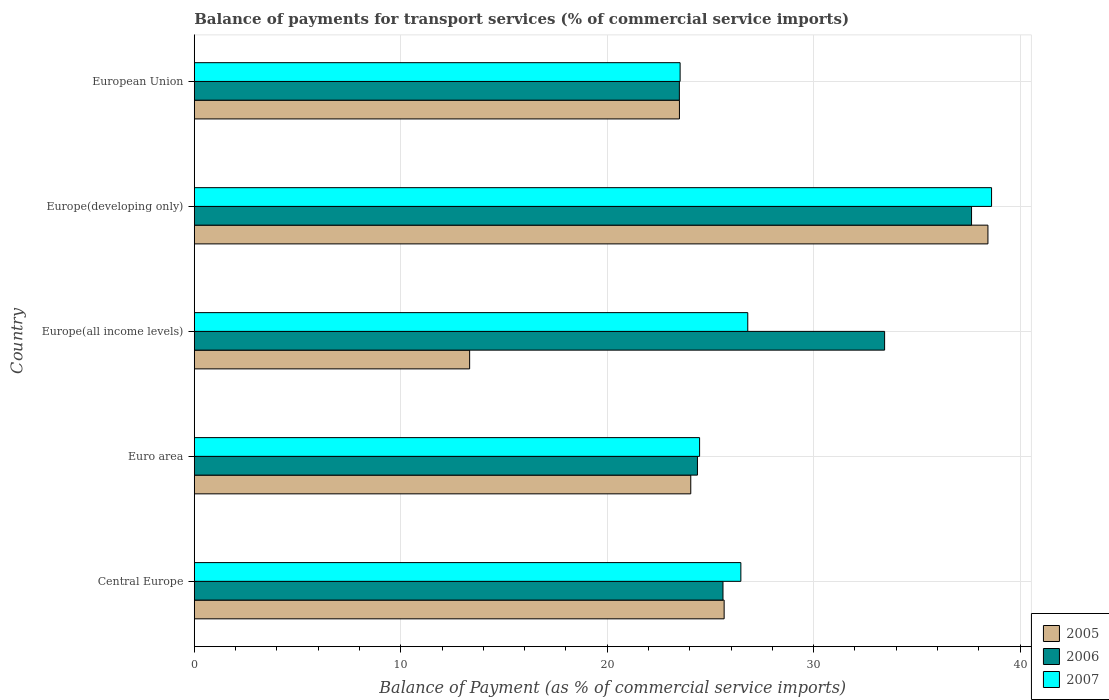Are the number of bars per tick equal to the number of legend labels?
Offer a very short reply. Yes. How many bars are there on the 5th tick from the top?
Make the answer very short. 3. How many bars are there on the 4th tick from the bottom?
Offer a terse response. 3. What is the balance of payments for transport services in 2005 in Central Europe?
Offer a very short reply. 25.66. Across all countries, what is the maximum balance of payments for transport services in 2005?
Offer a terse response. 38.44. Across all countries, what is the minimum balance of payments for transport services in 2007?
Your response must be concise. 23.53. In which country was the balance of payments for transport services in 2006 maximum?
Provide a short and direct response. Europe(developing only). In which country was the balance of payments for transport services in 2005 minimum?
Your answer should be very brief. Europe(all income levels). What is the total balance of payments for transport services in 2006 in the graph?
Give a very brief answer. 144.56. What is the difference between the balance of payments for transport services in 2005 in Central Europe and that in Europe(developing only)?
Your answer should be compact. -12.78. What is the difference between the balance of payments for transport services in 2007 in Europe(all income levels) and the balance of payments for transport services in 2006 in European Union?
Offer a very short reply. 3.31. What is the average balance of payments for transport services in 2007 per country?
Your answer should be compact. 27.98. What is the difference between the balance of payments for transport services in 2007 and balance of payments for transport services in 2005 in European Union?
Make the answer very short. 0.03. What is the ratio of the balance of payments for transport services in 2005 in Central Europe to that in Europe(developing only)?
Ensure brevity in your answer.  0.67. Is the balance of payments for transport services in 2007 in Central Europe less than that in Europe(all income levels)?
Make the answer very short. Yes. Is the difference between the balance of payments for transport services in 2007 in Central Europe and Europe(all income levels) greater than the difference between the balance of payments for transport services in 2005 in Central Europe and Europe(all income levels)?
Make the answer very short. No. What is the difference between the highest and the second highest balance of payments for transport services in 2005?
Provide a short and direct response. 12.78. What is the difference between the highest and the lowest balance of payments for transport services in 2006?
Give a very brief answer. 14.15. In how many countries, is the balance of payments for transport services in 2005 greater than the average balance of payments for transport services in 2005 taken over all countries?
Offer a very short reply. 2. Is the sum of the balance of payments for transport services in 2007 in Europe(developing only) and European Union greater than the maximum balance of payments for transport services in 2006 across all countries?
Offer a terse response. Yes. What does the 3rd bar from the top in Europe(all income levels) represents?
Give a very brief answer. 2005. Is it the case that in every country, the sum of the balance of payments for transport services in 2005 and balance of payments for transport services in 2007 is greater than the balance of payments for transport services in 2006?
Provide a short and direct response. Yes. How many countries are there in the graph?
Offer a very short reply. 5. What is the difference between two consecutive major ticks on the X-axis?
Keep it short and to the point. 10. Does the graph contain any zero values?
Provide a short and direct response. No. How many legend labels are there?
Your response must be concise. 3. How are the legend labels stacked?
Offer a very short reply. Vertical. What is the title of the graph?
Provide a succinct answer. Balance of payments for transport services (% of commercial service imports). Does "1982" appear as one of the legend labels in the graph?
Your answer should be very brief. No. What is the label or title of the X-axis?
Provide a short and direct response. Balance of Payment (as % of commercial service imports). What is the Balance of Payment (as % of commercial service imports) of 2005 in Central Europe?
Ensure brevity in your answer.  25.66. What is the Balance of Payment (as % of commercial service imports) of 2006 in Central Europe?
Ensure brevity in your answer.  25.61. What is the Balance of Payment (as % of commercial service imports) of 2007 in Central Europe?
Give a very brief answer. 26.47. What is the Balance of Payment (as % of commercial service imports) of 2005 in Euro area?
Your answer should be very brief. 24.05. What is the Balance of Payment (as % of commercial service imports) in 2006 in Euro area?
Make the answer very short. 24.37. What is the Balance of Payment (as % of commercial service imports) in 2007 in Euro area?
Provide a short and direct response. 24.47. What is the Balance of Payment (as % of commercial service imports) in 2005 in Europe(all income levels)?
Offer a very short reply. 13.34. What is the Balance of Payment (as % of commercial service imports) in 2006 in Europe(all income levels)?
Ensure brevity in your answer.  33.44. What is the Balance of Payment (as % of commercial service imports) in 2007 in Europe(all income levels)?
Offer a very short reply. 26.81. What is the Balance of Payment (as % of commercial service imports) of 2005 in Europe(developing only)?
Give a very brief answer. 38.44. What is the Balance of Payment (as % of commercial service imports) in 2006 in Europe(developing only)?
Your answer should be very brief. 37.65. What is the Balance of Payment (as % of commercial service imports) of 2007 in Europe(developing only)?
Offer a terse response. 38.62. What is the Balance of Payment (as % of commercial service imports) in 2005 in European Union?
Make the answer very short. 23.5. What is the Balance of Payment (as % of commercial service imports) of 2006 in European Union?
Offer a very short reply. 23.5. What is the Balance of Payment (as % of commercial service imports) in 2007 in European Union?
Your answer should be compact. 23.53. Across all countries, what is the maximum Balance of Payment (as % of commercial service imports) in 2005?
Offer a very short reply. 38.44. Across all countries, what is the maximum Balance of Payment (as % of commercial service imports) of 2006?
Offer a terse response. 37.65. Across all countries, what is the maximum Balance of Payment (as % of commercial service imports) in 2007?
Your response must be concise. 38.62. Across all countries, what is the minimum Balance of Payment (as % of commercial service imports) of 2005?
Give a very brief answer. 13.34. Across all countries, what is the minimum Balance of Payment (as % of commercial service imports) of 2006?
Keep it short and to the point. 23.5. Across all countries, what is the minimum Balance of Payment (as % of commercial service imports) in 2007?
Provide a succinct answer. 23.53. What is the total Balance of Payment (as % of commercial service imports) of 2005 in the graph?
Give a very brief answer. 124.99. What is the total Balance of Payment (as % of commercial service imports) of 2006 in the graph?
Give a very brief answer. 144.56. What is the total Balance of Payment (as % of commercial service imports) of 2007 in the graph?
Your answer should be very brief. 139.9. What is the difference between the Balance of Payment (as % of commercial service imports) of 2005 in Central Europe and that in Euro area?
Make the answer very short. 1.62. What is the difference between the Balance of Payment (as % of commercial service imports) of 2006 in Central Europe and that in Euro area?
Make the answer very short. 1.24. What is the difference between the Balance of Payment (as % of commercial service imports) in 2007 in Central Europe and that in Euro area?
Give a very brief answer. 2. What is the difference between the Balance of Payment (as % of commercial service imports) of 2005 in Central Europe and that in Europe(all income levels)?
Provide a short and direct response. 12.33. What is the difference between the Balance of Payment (as % of commercial service imports) in 2006 in Central Europe and that in Europe(all income levels)?
Ensure brevity in your answer.  -7.83. What is the difference between the Balance of Payment (as % of commercial service imports) of 2007 in Central Europe and that in Europe(all income levels)?
Your answer should be very brief. -0.33. What is the difference between the Balance of Payment (as % of commercial service imports) of 2005 in Central Europe and that in Europe(developing only)?
Your answer should be very brief. -12.78. What is the difference between the Balance of Payment (as % of commercial service imports) in 2006 in Central Europe and that in Europe(developing only)?
Offer a very short reply. -12.04. What is the difference between the Balance of Payment (as % of commercial service imports) of 2007 in Central Europe and that in Europe(developing only)?
Keep it short and to the point. -12.14. What is the difference between the Balance of Payment (as % of commercial service imports) in 2005 in Central Europe and that in European Union?
Your answer should be very brief. 2.16. What is the difference between the Balance of Payment (as % of commercial service imports) of 2006 in Central Europe and that in European Union?
Your answer should be very brief. 2.11. What is the difference between the Balance of Payment (as % of commercial service imports) in 2007 in Central Europe and that in European Union?
Provide a short and direct response. 2.94. What is the difference between the Balance of Payment (as % of commercial service imports) in 2005 in Euro area and that in Europe(all income levels)?
Offer a terse response. 10.71. What is the difference between the Balance of Payment (as % of commercial service imports) in 2006 in Euro area and that in Europe(all income levels)?
Your answer should be compact. -9.06. What is the difference between the Balance of Payment (as % of commercial service imports) of 2007 in Euro area and that in Europe(all income levels)?
Your answer should be compact. -2.33. What is the difference between the Balance of Payment (as % of commercial service imports) of 2005 in Euro area and that in Europe(developing only)?
Your answer should be compact. -14.39. What is the difference between the Balance of Payment (as % of commercial service imports) in 2006 in Euro area and that in Europe(developing only)?
Provide a succinct answer. -13.28. What is the difference between the Balance of Payment (as % of commercial service imports) of 2007 in Euro area and that in Europe(developing only)?
Offer a terse response. -14.14. What is the difference between the Balance of Payment (as % of commercial service imports) in 2005 in Euro area and that in European Union?
Give a very brief answer. 0.55. What is the difference between the Balance of Payment (as % of commercial service imports) in 2006 in Euro area and that in European Union?
Make the answer very short. 0.88. What is the difference between the Balance of Payment (as % of commercial service imports) of 2007 in Euro area and that in European Union?
Your answer should be compact. 0.94. What is the difference between the Balance of Payment (as % of commercial service imports) of 2005 in Europe(all income levels) and that in Europe(developing only)?
Make the answer very short. -25.1. What is the difference between the Balance of Payment (as % of commercial service imports) in 2006 in Europe(all income levels) and that in Europe(developing only)?
Your answer should be very brief. -4.21. What is the difference between the Balance of Payment (as % of commercial service imports) of 2007 in Europe(all income levels) and that in Europe(developing only)?
Ensure brevity in your answer.  -11.81. What is the difference between the Balance of Payment (as % of commercial service imports) of 2005 in Europe(all income levels) and that in European Union?
Offer a terse response. -10.16. What is the difference between the Balance of Payment (as % of commercial service imports) in 2006 in Europe(all income levels) and that in European Union?
Your response must be concise. 9.94. What is the difference between the Balance of Payment (as % of commercial service imports) in 2007 in Europe(all income levels) and that in European Union?
Your answer should be very brief. 3.28. What is the difference between the Balance of Payment (as % of commercial service imports) of 2005 in Europe(developing only) and that in European Union?
Give a very brief answer. 14.94. What is the difference between the Balance of Payment (as % of commercial service imports) in 2006 in Europe(developing only) and that in European Union?
Offer a very short reply. 14.15. What is the difference between the Balance of Payment (as % of commercial service imports) in 2007 in Europe(developing only) and that in European Union?
Give a very brief answer. 15.09. What is the difference between the Balance of Payment (as % of commercial service imports) in 2005 in Central Europe and the Balance of Payment (as % of commercial service imports) in 2006 in Euro area?
Provide a short and direct response. 1.29. What is the difference between the Balance of Payment (as % of commercial service imports) in 2005 in Central Europe and the Balance of Payment (as % of commercial service imports) in 2007 in Euro area?
Offer a terse response. 1.19. What is the difference between the Balance of Payment (as % of commercial service imports) of 2006 in Central Europe and the Balance of Payment (as % of commercial service imports) of 2007 in Euro area?
Ensure brevity in your answer.  1.13. What is the difference between the Balance of Payment (as % of commercial service imports) of 2005 in Central Europe and the Balance of Payment (as % of commercial service imports) of 2006 in Europe(all income levels)?
Offer a very short reply. -7.77. What is the difference between the Balance of Payment (as % of commercial service imports) in 2005 in Central Europe and the Balance of Payment (as % of commercial service imports) in 2007 in Europe(all income levels)?
Offer a very short reply. -1.14. What is the difference between the Balance of Payment (as % of commercial service imports) in 2006 in Central Europe and the Balance of Payment (as % of commercial service imports) in 2007 in Europe(all income levels)?
Make the answer very short. -1.2. What is the difference between the Balance of Payment (as % of commercial service imports) of 2005 in Central Europe and the Balance of Payment (as % of commercial service imports) of 2006 in Europe(developing only)?
Offer a terse response. -11.98. What is the difference between the Balance of Payment (as % of commercial service imports) of 2005 in Central Europe and the Balance of Payment (as % of commercial service imports) of 2007 in Europe(developing only)?
Your answer should be very brief. -12.95. What is the difference between the Balance of Payment (as % of commercial service imports) of 2006 in Central Europe and the Balance of Payment (as % of commercial service imports) of 2007 in Europe(developing only)?
Give a very brief answer. -13.01. What is the difference between the Balance of Payment (as % of commercial service imports) in 2005 in Central Europe and the Balance of Payment (as % of commercial service imports) in 2006 in European Union?
Make the answer very short. 2.17. What is the difference between the Balance of Payment (as % of commercial service imports) of 2005 in Central Europe and the Balance of Payment (as % of commercial service imports) of 2007 in European Union?
Ensure brevity in your answer.  2.13. What is the difference between the Balance of Payment (as % of commercial service imports) in 2006 in Central Europe and the Balance of Payment (as % of commercial service imports) in 2007 in European Union?
Provide a short and direct response. 2.08. What is the difference between the Balance of Payment (as % of commercial service imports) of 2005 in Euro area and the Balance of Payment (as % of commercial service imports) of 2006 in Europe(all income levels)?
Your answer should be very brief. -9.39. What is the difference between the Balance of Payment (as % of commercial service imports) in 2005 in Euro area and the Balance of Payment (as % of commercial service imports) in 2007 in Europe(all income levels)?
Your answer should be compact. -2.76. What is the difference between the Balance of Payment (as % of commercial service imports) of 2006 in Euro area and the Balance of Payment (as % of commercial service imports) of 2007 in Europe(all income levels)?
Offer a very short reply. -2.44. What is the difference between the Balance of Payment (as % of commercial service imports) of 2005 in Euro area and the Balance of Payment (as % of commercial service imports) of 2006 in Europe(developing only)?
Keep it short and to the point. -13.6. What is the difference between the Balance of Payment (as % of commercial service imports) in 2005 in Euro area and the Balance of Payment (as % of commercial service imports) in 2007 in Europe(developing only)?
Give a very brief answer. -14.57. What is the difference between the Balance of Payment (as % of commercial service imports) of 2006 in Euro area and the Balance of Payment (as % of commercial service imports) of 2007 in Europe(developing only)?
Offer a very short reply. -14.25. What is the difference between the Balance of Payment (as % of commercial service imports) of 2005 in Euro area and the Balance of Payment (as % of commercial service imports) of 2006 in European Union?
Your answer should be compact. 0.55. What is the difference between the Balance of Payment (as % of commercial service imports) in 2005 in Euro area and the Balance of Payment (as % of commercial service imports) in 2007 in European Union?
Your response must be concise. 0.52. What is the difference between the Balance of Payment (as % of commercial service imports) of 2006 in Euro area and the Balance of Payment (as % of commercial service imports) of 2007 in European Union?
Your answer should be compact. 0.84. What is the difference between the Balance of Payment (as % of commercial service imports) in 2005 in Europe(all income levels) and the Balance of Payment (as % of commercial service imports) in 2006 in Europe(developing only)?
Provide a succinct answer. -24.31. What is the difference between the Balance of Payment (as % of commercial service imports) in 2005 in Europe(all income levels) and the Balance of Payment (as % of commercial service imports) in 2007 in Europe(developing only)?
Offer a very short reply. -25.28. What is the difference between the Balance of Payment (as % of commercial service imports) of 2006 in Europe(all income levels) and the Balance of Payment (as % of commercial service imports) of 2007 in Europe(developing only)?
Offer a terse response. -5.18. What is the difference between the Balance of Payment (as % of commercial service imports) of 2005 in Europe(all income levels) and the Balance of Payment (as % of commercial service imports) of 2006 in European Union?
Offer a terse response. -10.16. What is the difference between the Balance of Payment (as % of commercial service imports) in 2005 in Europe(all income levels) and the Balance of Payment (as % of commercial service imports) in 2007 in European Union?
Your response must be concise. -10.19. What is the difference between the Balance of Payment (as % of commercial service imports) in 2006 in Europe(all income levels) and the Balance of Payment (as % of commercial service imports) in 2007 in European Union?
Give a very brief answer. 9.9. What is the difference between the Balance of Payment (as % of commercial service imports) in 2005 in Europe(developing only) and the Balance of Payment (as % of commercial service imports) in 2006 in European Union?
Ensure brevity in your answer.  14.94. What is the difference between the Balance of Payment (as % of commercial service imports) of 2005 in Europe(developing only) and the Balance of Payment (as % of commercial service imports) of 2007 in European Union?
Provide a succinct answer. 14.91. What is the difference between the Balance of Payment (as % of commercial service imports) in 2006 in Europe(developing only) and the Balance of Payment (as % of commercial service imports) in 2007 in European Union?
Offer a terse response. 14.12. What is the average Balance of Payment (as % of commercial service imports) in 2005 per country?
Your response must be concise. 25. What is the average Balance of Payment (as % of commercial service imports) of 2006 per country?
Offer a very short reply. 28.91. What is the average Balance of Payment (as % of commercial service imports) in 2007 per country?
Offer a terse response. 27.98. What is the difference between the Balance of Payment (as % of commercial service imports) of 2005 and Balance of Payment (as % of commercial service imports) of 2006 in Central Europe?
Your answer should be very brief. 0.06. What is the difference between the Balance of Payment (as % of commercial service imports) in 2005 and Balance of Payment (as % of commercial service imports) in 2007 in Central Europe?
Your answer should be very brief. -0.81. What is the difference between the Balance of Payment (as % of commercial service imports) in 2006 and Balance of Payment (as % of commercial service imports) in 2007 in Central Europe?
Provide a succinct answer. -0.87. What is the difference between the Balance of Payment (as % of commercial service imports) in 2005 and Balance of Payment (as % of commercial service imports) in 2006 in Euro area?
Give a very brief answer. -0.32. What is the difference between the Balance of Payment (as % of commercial service imports) in 2005 and Balance of Payment (as % of commercial service imports) in 2007 in Euro area?
Your response must be concise. -0.43. What is the difference between the Balance of Payment (as % of commercial service imports) in 2006 and Balance of Payment (as % of commercial service imports) in 2007 in Euro area?
Provide a short and direct response. -0.1. What is the difference between the Balance of Payment (as % of commercial service imports) in 2005 and Balance of Payment (as % of commercial service imports) in 2006 in Europe(all income levels)?
Provide a short and direct response. -20.1. What is the difference between the Balance of Payment (as % of commercial service imports) of 2005 and Balance of Payment (as % of commercial service imports) of 2007 in Europe(all income levels)?
Provide a succinct answer. -13.47. What is the difference between the Balance of Payment (as % of commercial service imports) in 2006 and Balance of Payment (as % of commercial service imports) in 2007 in Europe(all income levels)?
Offer a very short reply. 6.63. What is the difference between the Balance of Payment (as % of commercial service imports) of 2005 and Balance of Payment (as % of commercial service imports) of 2006 in Europe(developing only)?
Your answer should be compact. 0.79. What is the difference between the Balance of Payment (as % of commercial service imports) of 2005 and Balance of Payment (as % of commercial service imports) of 2007 in Europe(developing only)?
Provide a short and direct response. -0.18. What is the difference between the Balance of Payment (as % of commercial service imports) in 2006 and Balance of Payment (as % of commercial service imports) in 2007 in Europe(developing only)?
Provide a short and direct response. -0.97. What is the difference between the Balance of Payment (as % of commercial service imports) in 2005 and Balance of Payment (as % of commercial service imports) in 2006 in European Union?
Ensure brevity in your answer.  0. What is the difference between the Balance of Payment (as % of commercial service imports) in 2005 and Balance of Payment (as % of commercial service imports) in 2007 in European Union?
Ensure brevity in your answer.  -0.03. What is the difference between the Balance of Payment (as % of commercial service imports) in 2006 and Balance of Payment (as % of commercial service imports) in 2007 in European Union?
Keep it short and to the point. -0.04. What is the ratio of the Balance of Payment (as % of commercial service imports) in 2005 in Central Europe to that in Euro area?
Your answer should be very brief. 1.07. What is the ratio of the Balance of Payment (as % of commercial service imports) in 2006 in Central Europe to that in Euro area?
Ensure brevity in your answer.  1.05. What is the ratio of the Balance of Payment (as % of commercial service imports) of 2007 in Central Europe to that in Euro area?
Your answer should be compact. 1.08. What is the ratio of the Balance of Payment (as % of commercial service imports) in 2005 in Central Europe to that in Europe(all income levels)?
Ensure brevity in your answer.  1.92. What is the ratio of the Balance of Payment (as % of commercial service imports) of 2006 in Central Europe to that in Europe(all income levels)?
Provide a succinct answer. 0.77. What is the ratio of the Balance of Payment (as % of commercial service imports) in 2007 in Central Europe to that in Europe(all income levels)?
Your response must be concise. 0.99. What is the ratio of the Balance of Payment (as % of commercial service imports) of 2005 in Central Europe to that in Europe(developing only)?
Offer a terse response. 0.67. What is the ratio of the Balance of Payment (as % of commercial service imports) in 2006 in Central Europe to that in Europe(developing only)?
Provide a short and direct response. 0.68. What is the ratio of the Balance of Payment (as % of commercial service imports) of 2007 in Central Europe to that in Europe(developing only)?
Give a very brief answer. 0.69. What is the ratio of the Balance of Payment (as % of commercial service imports) of 2005 in Central Europe to that in European Union?
Give a very brief answer. 1.09. What is the ratio of the Balance of Payment (as % of commercial service imports) of 2006 in Central Europe to that in European Union?
Provide a succinct answer. 1.09. What is the ratio of the Balance of Payment (as % of commercial service imports) in 2007 in Central Europe to that in European Union?
Make the answer very short. 1.12. What is the ratio of the Balance of Payment (as % of commercial service imports) in 2005 in Euro area to that in Europe(all income levels)?
Provide a short and direct response. 1.8. What is the ratio of the Balance of Payment (as % of commercial service imports) of 2006 in Euro area to that in Europe(all income levels)?
Give a very brief answer. 0.73. What is the ratio of the Balance of Payment (as % of commercial service imports) of 2005 in Euro area to that in Europe(developing only)?
Provide a short and direct response. 0.63. What is the ratio of the Balance of Payment (as % of commercial service imports) in 2006 in Euro area to that in Europe(developing only)?
Ensure brevity in your answer.  0.65. What is the ratio of the Balance of Payment (as % of commercial service imports) of 2007 in Euro area to that in Europe(developing only)?
Make the answer very short. 0.63. What is the ratio of the Balance of Payment (as % of commercial service imports) in 2005 in Euro area to that in European Union?
Provide a short and direct response. 1.02. What is the ratio of the Balance of Payment (as % of commercial service imports) of 2006 in Euro area to that in European Union?
Ensure brevity in your answer.  1.04. What is the ratio of the Balance of Payment (as % of commercial service imports) of 2007 in Euro area to that in European Union?
Offer a very short reply. 1.04. What is the ratio of the Balance of Payment (as % of commercial service imports) of 2005 in Europe(all income levels) to that in Europe(developing only)?
Make the answer very short. 0.35. What is the ratio of the Balance of Payment (as % of commercial service imports) of 2006 in Europe(all income levels) to that in Europe(developing only)?
Your answer should be compact. 0.89. What is the ratio of the Balance of Payment (as % of commercial service imports) of 2007 in Europe(all income levels) to that in Europe(developing only)?
Your answer should be compact. 0.69. What is the ratio of the Balance of Payment (as % of commercial service imports) in 2005 in Europe(all income levels) to that in European Union?
Make the answer very short. 0.57. What is the ratio of the Balance of Payment (as % of commercial service imports) of 2006 in Europe(all income levels) to that in European Union?
Your response must be concise. 1.42. What is the ratio of the Balance of Payment (as % of commercial service imports) of 2007 in Europe(all income levels) to that in European Union?
Offer a terse response. 1.14. What is the ratio of the Balance of Payment (as % of commercial service imports) in 2005 in Europe(developing only) to that in European Union?
Your answer should be very brief. 1.64. What is the ratio of the Balance of Payment (as % of commercial service imports) of 2006 in Europe(developing only) to that in European Union?
Provide a short and direct response. 1.6. What is the ratio of the Balance of Payment (as % of commercial service imports) of 2007 in Europe(developing only) to that in European Union?
Provide a short and direct response. 1.64. What is the difference between the highest and the second highest Balance of Payment (as % of commercial service imports) in 2005?
Offer a very short reply. 12.78. What is the difference between the highest and the second highest Balance of Payment (as % of commercial service imports) of 2006?
Keep it short and to the point. 4.21. What is the difference between the highest and the second highest Balance of Payment (as % of commercial service imports) of 2007?
Make the answer very short. 11.81. What is the difference between the highest and the lowest Balance of Payment (as % of commercial service imports) in 2005?
Offer a terse response. 25.1. What is the difference between the highest and the lowest Balance of Payment (as % of commercial service imports) in 2006?
Your answer should be very brief. 14.15. What is the difference between the highest and the lowest Balance of Payment (as % of commercial service imports) in 2007?
Offer a very short reply. 15.09. 